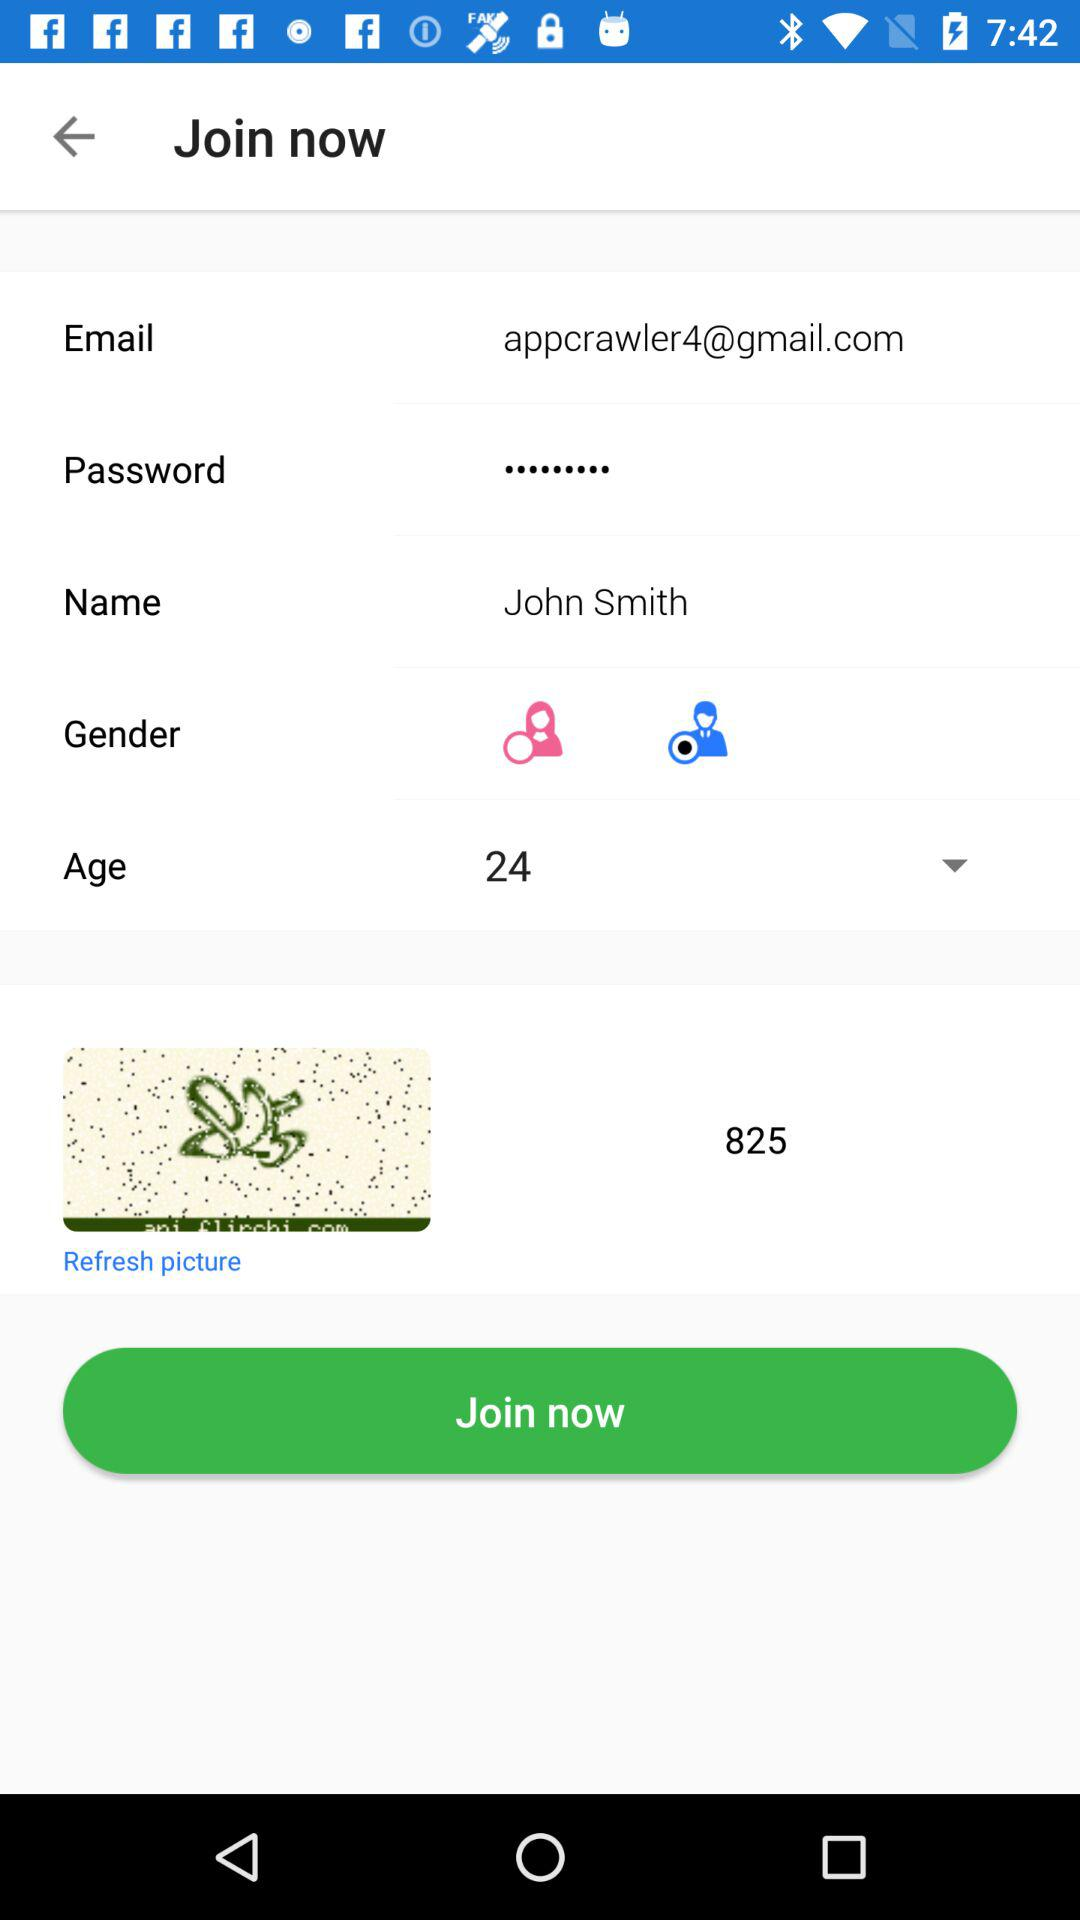What is the selected gender? The selected gender is male. 